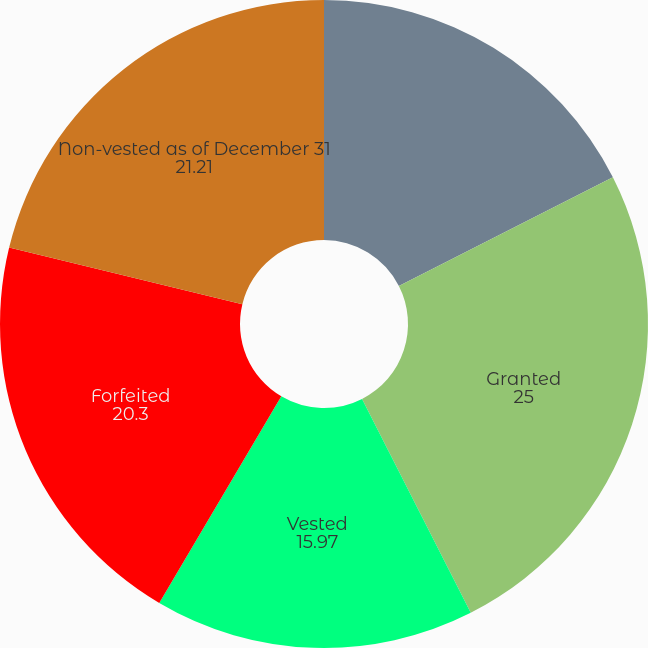<chart> <loc_0><loc_0><loc_500><loc_500><pie_chart><fcel>Non-vested as of January 1<fcel>Granted<fcel>Vested<fcel>Forfeited<fcel>Non-vested as of December 31<nl><fcel>17.52%<fcel>25.0%<fcel>15.97%<fcel>20.3%<fcel>21.21%<nl></chart> 